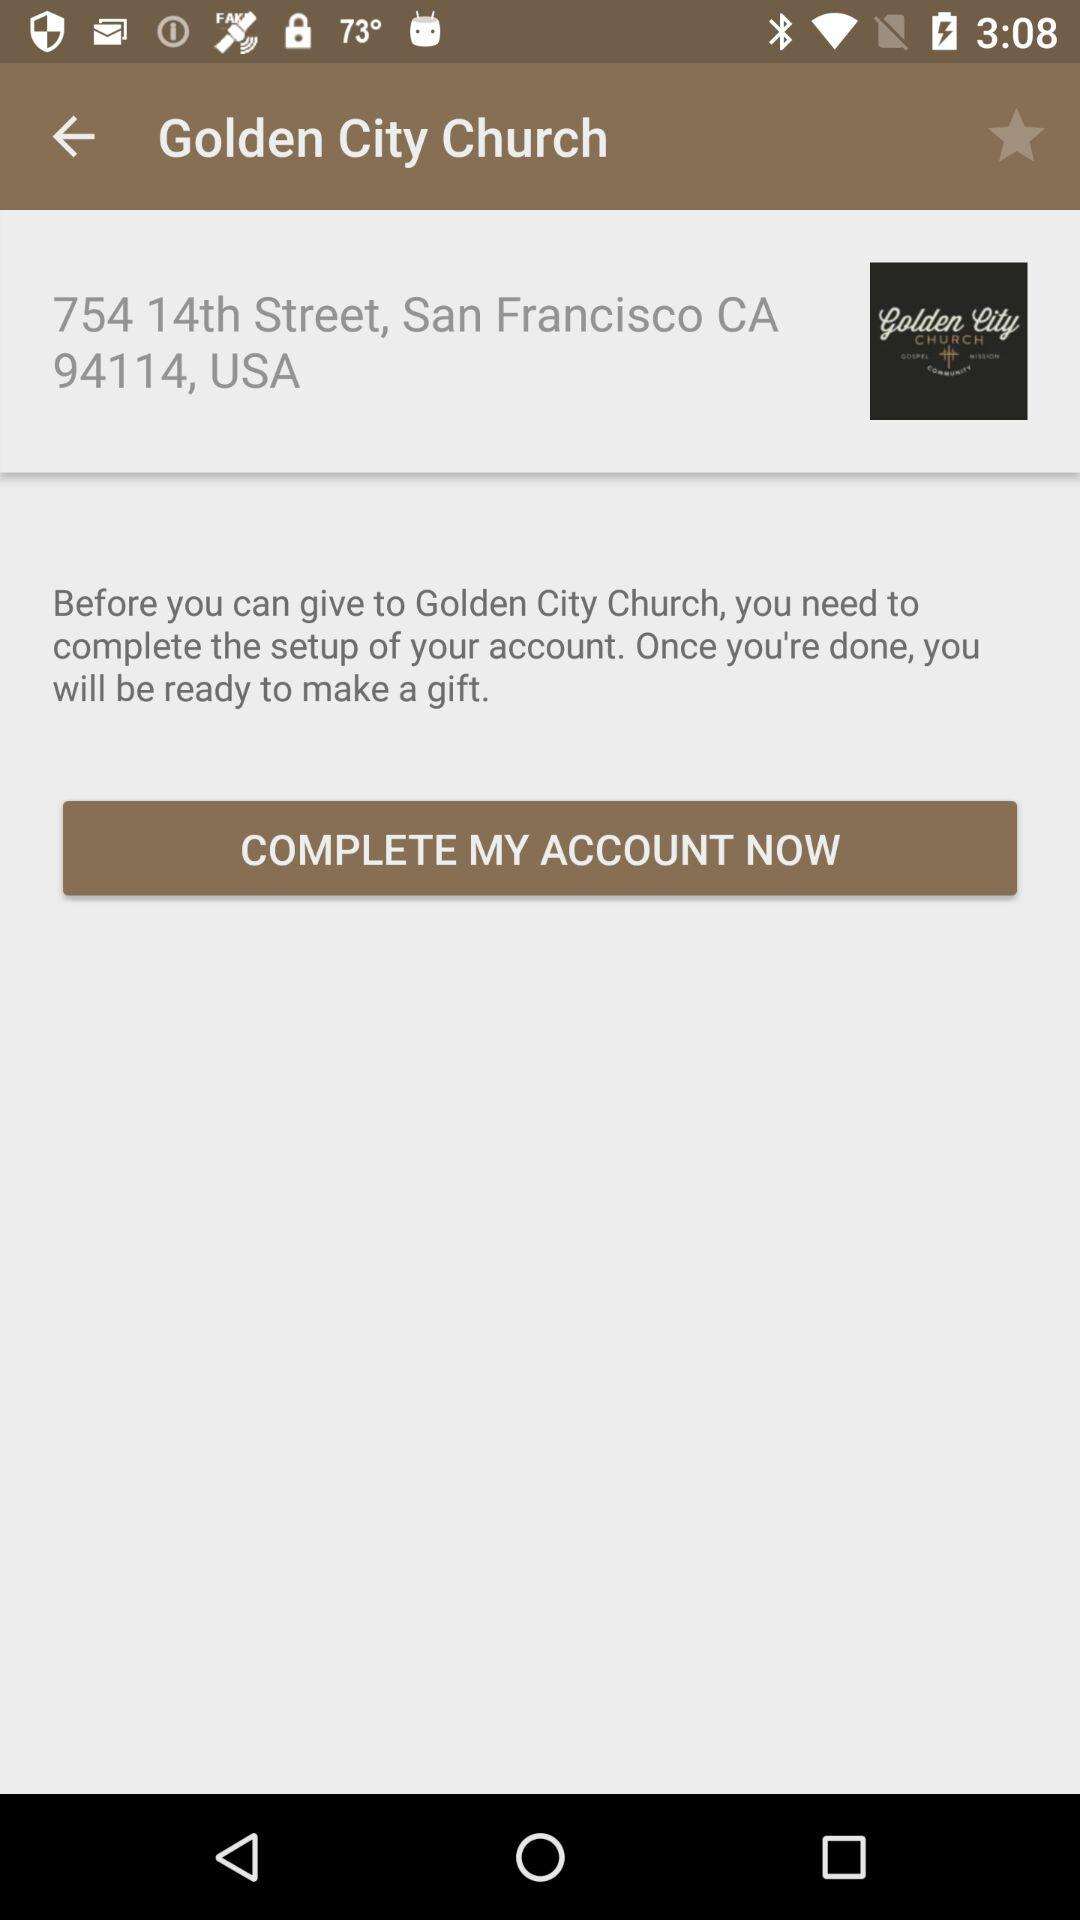What is the requirement before gifting to Golden City Church? Before gifting to Golden City Church, one needs to complete the setup of the account. 